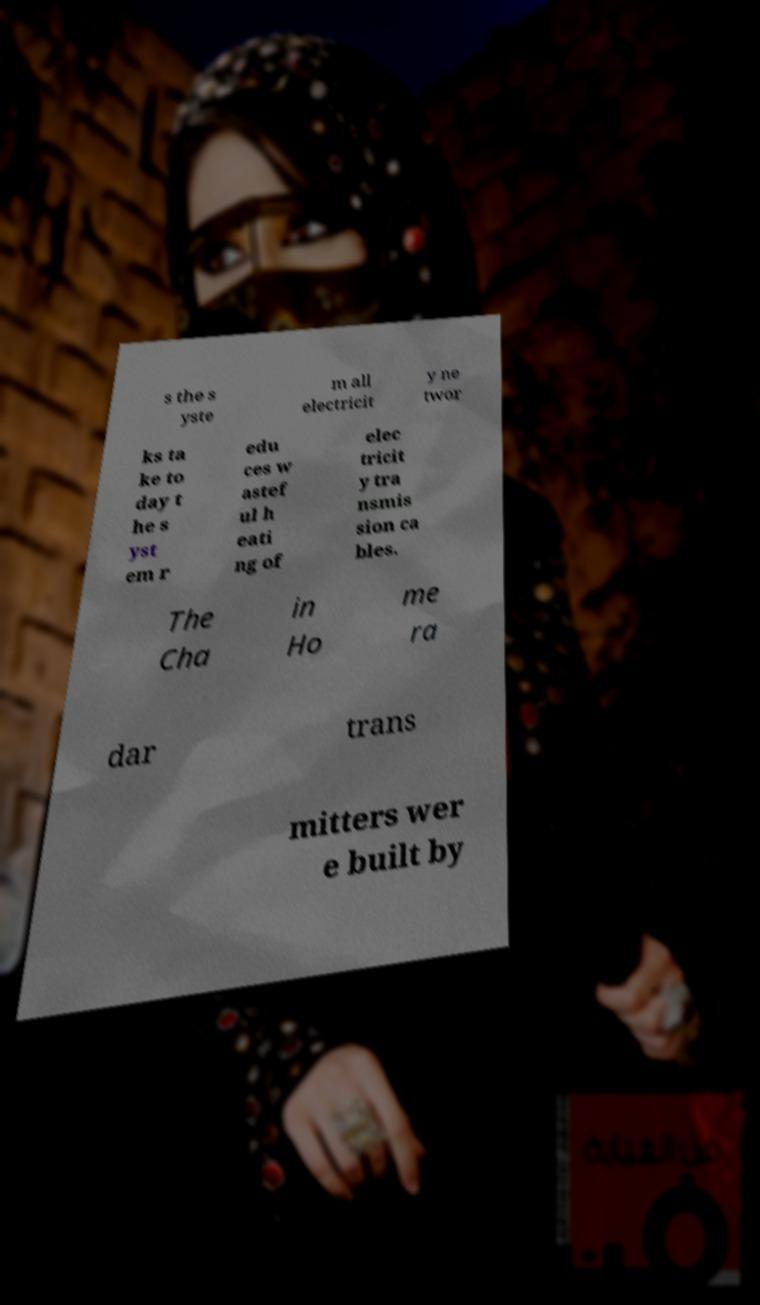What messages or text are displayed in this image? I need them in a readable, typed format. s the s yste m all electricit y ne twor ks ta ke to day t he s yst em r edu ces w astef ul h eati ng of elec tricit y tra nsmis sion ca bles. The Cha in Ho me ra dar trans mitters wer e built by 